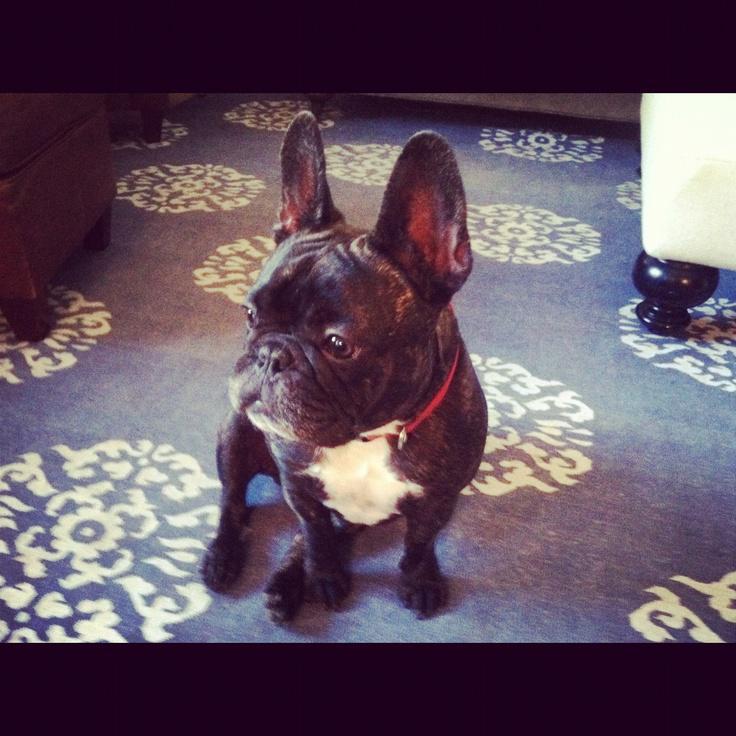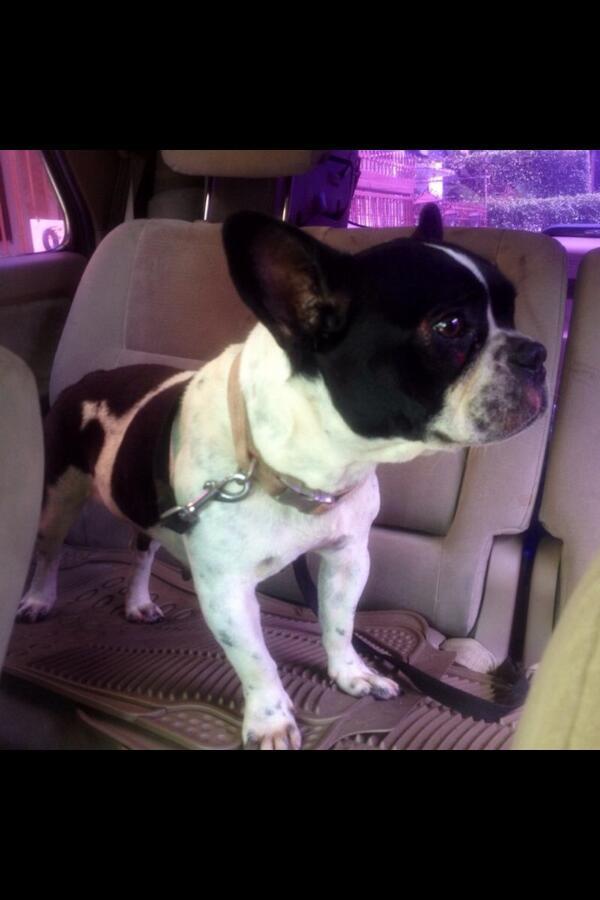The first image is the image on the left, the second image is the image on the right. Analyze the images presented: Is the assertion "At least two dogs are wearing costumes." valid? Answer yes or no. No. The first image is the image on the left, the second image is the image on the right. Given the left and right images, does the statement "A dog can be seen sitting on a carpet." hold true? Answer yes or no. Yes. 